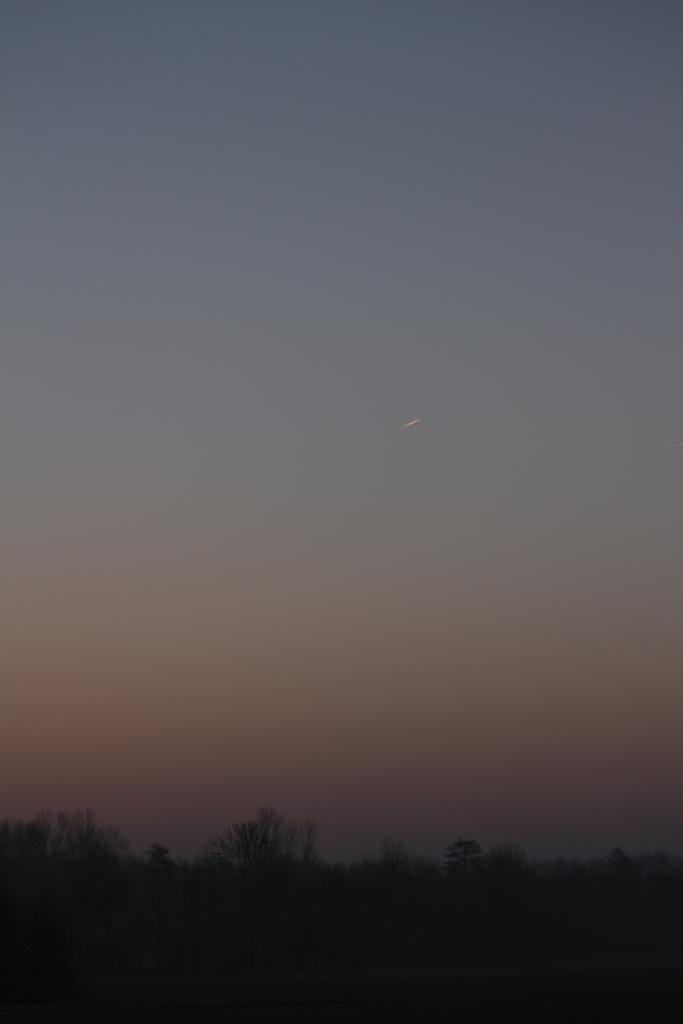What time of day was the image taken? The image was taken at night. What can be seen at the bottom of the image? There are trees at the bottom of the image. What is visible at the top of the image? The sky is visible at the top of the image. Can you see a monkey swinging from a tree in the image? There is no monkey present in the image; it only features trees and the night sky. 